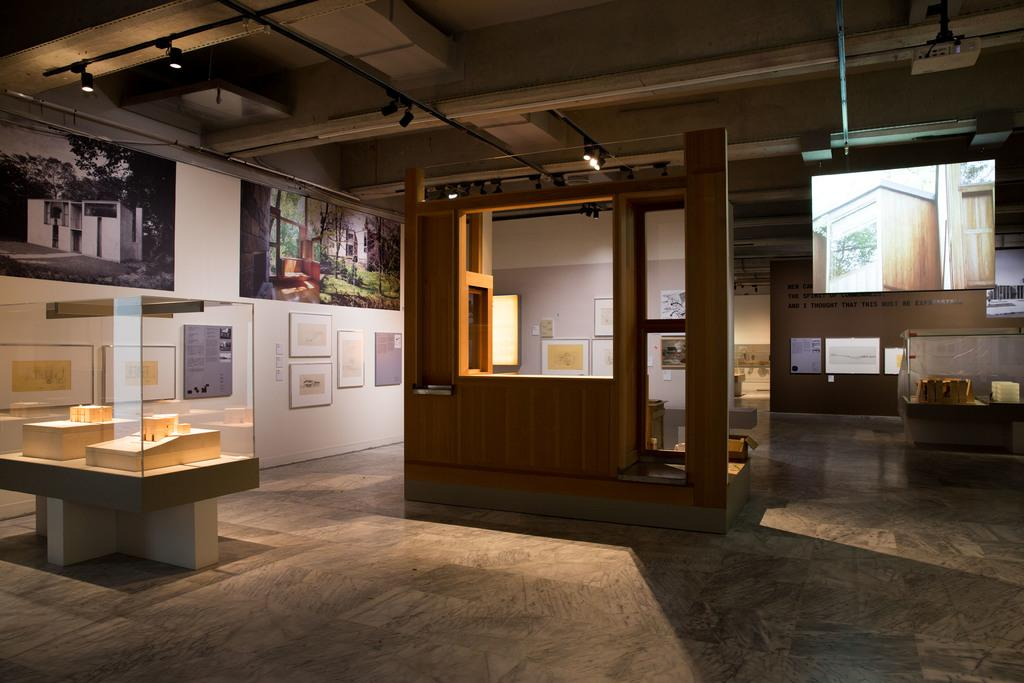What type of glass object is in the image? The fact does not specify the type of glass object, only that there is a glass object in the image. What is the wooden item in the image made of? The wooden item in the image is made of wood. What can be seen on the wall in the background of the image? The wall in the background of the image has photos and other things on it. Where are the lights located in the image? The lights are visible at the top of the image. Who is the owner of the town in the image? There is no town present in the image, so there is no owner to discuss. 